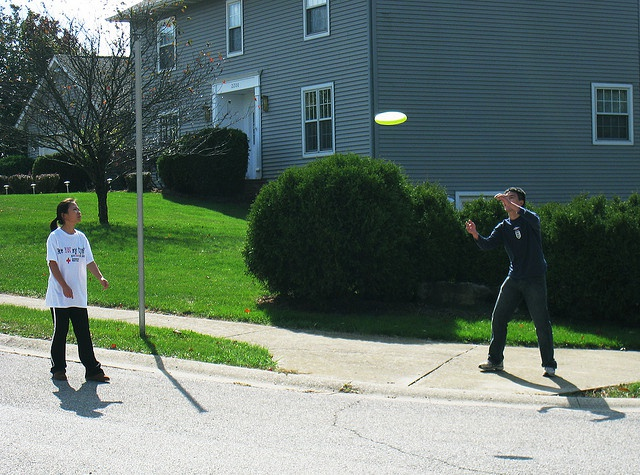Describe the objects in this image and their specific colors. I can see people in white, black, darkgray, lightgray, and green tones, people in white, black, gray, and ivory tones, and frisbee in white and yellow tones in this image. 